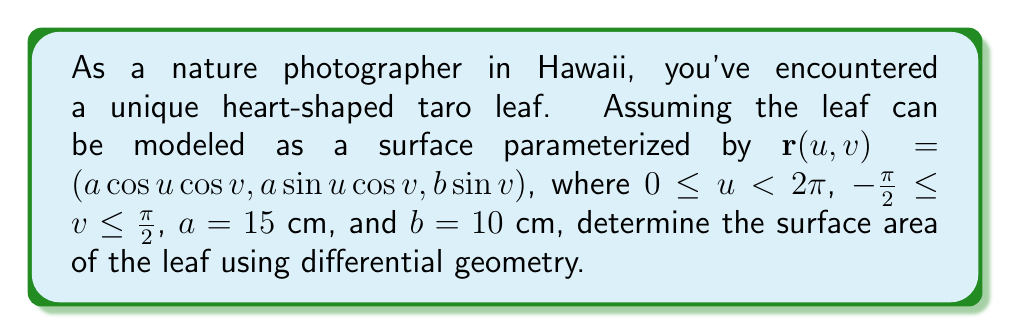Help me with this question. To find the surface area using differential geometry, we need to follow these steps:

1) First, we need to calculate the partial derivatives of $\mathbf{r}$ with respect to $u$ and $v$:

   $\mathbf{r}_u = (-a\sin u \cos v, a\cos u \cos v, 0)$
   $\mathbf{r}_v = (-a\cos u \sin v, -a\sin u \sin v, b\cos v)$

2) Next, we compute the cross product $\mathbf{r}_u \times \mathbf{r}_v$:

   $\mathbf{r}_u \times \mathbf{r}_v = (ab\cos u \cos^2 v, ab\sin u \cos^2 v, a^2\cos v)$

3) The magnitude of this cross product gives us the surface element:

   $\|\mathbf{r}_u \times \mathbf{r}_v\| = \sqrt{(ab\cos u \cos^2 v)^2 + (ab\sin u \cos^2 v)^2 + (a^2\cos v)^2}$
   
   $= \sqrt{a^2b^2\cos^4 v + a^4\cos^2 v}$
   
   $= a\cos v\sqrt{b^2\cos^2 v + a^2}$

4) The surface area is then given by the double integral:

   $A = \int\int_S \|\mathbf{r}_u \times \mathbf{r}_v\| \,du\,dv$
   
   $= \int_0^{2\pi} \int_{-\pi/2}^{\pi/2} a\cos v\sqrt{b^2\cos^2 v + a^2} \,dv\,du$

5) Simplify the integral:

   $A = 2\pi a \int_{-\pi/2}^{\pi/2} \cos v\sqrt{b^2\cos^2 v + a^2} \,dv$

6) This integral doesn't have an elementary antiderivative, but it can be evaluated in terms of elliptic integrals. The result is:

   $A = 2\pi a^2 \,E(\frac{b}{a})$

   Where $E(k)$ is the complete elliptic integral of the second kind.

7) Substituting the given values $a = 15$ cm and $b = 10$ cm:

   $A = 2\pi (15)^2 \,E(\frac{10}{15}) = 450\pi \,E(\frac{2}{3})$

8) The value of $E(\frac{2}{3})$ is approximately 1.2111, so:

   $A \approx 450\pi (1.2111) \approx 1710.9$ cm²
Answer: The surface area of the leaf is approximately 1710.9 cm². 